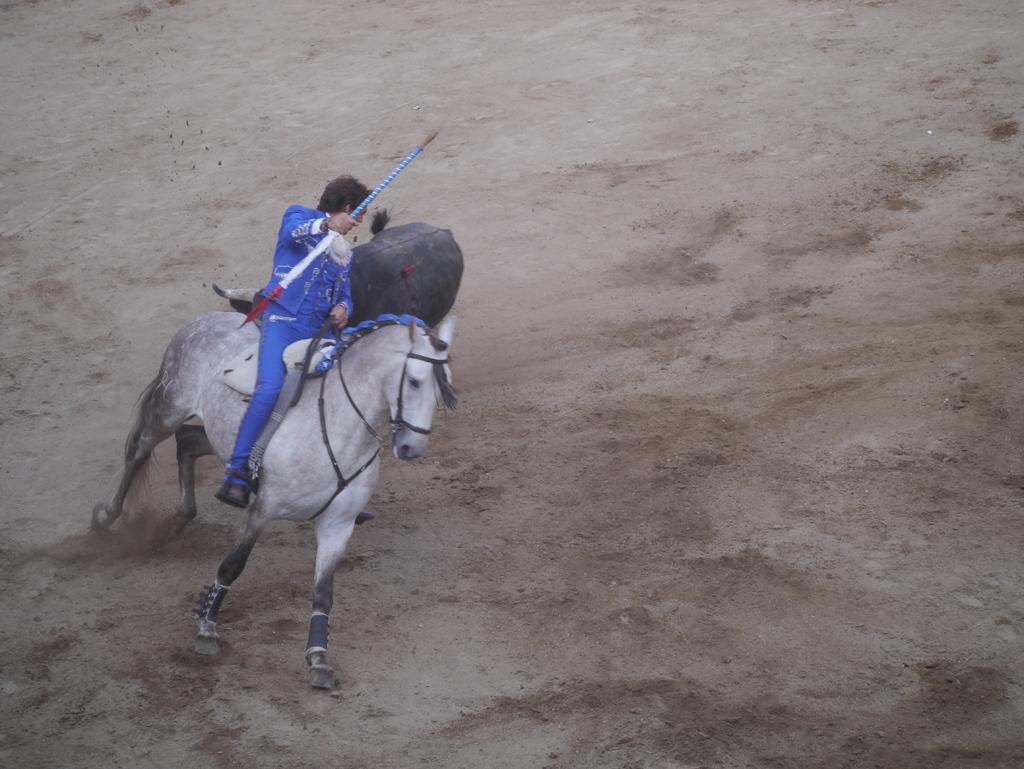In one or two sentences, can you explain what this image depicts? In the image we can see a man wearing clothes, shoes and holding stick in hand and he is riding on the horse. Here we can see sand and other animal black in color. 